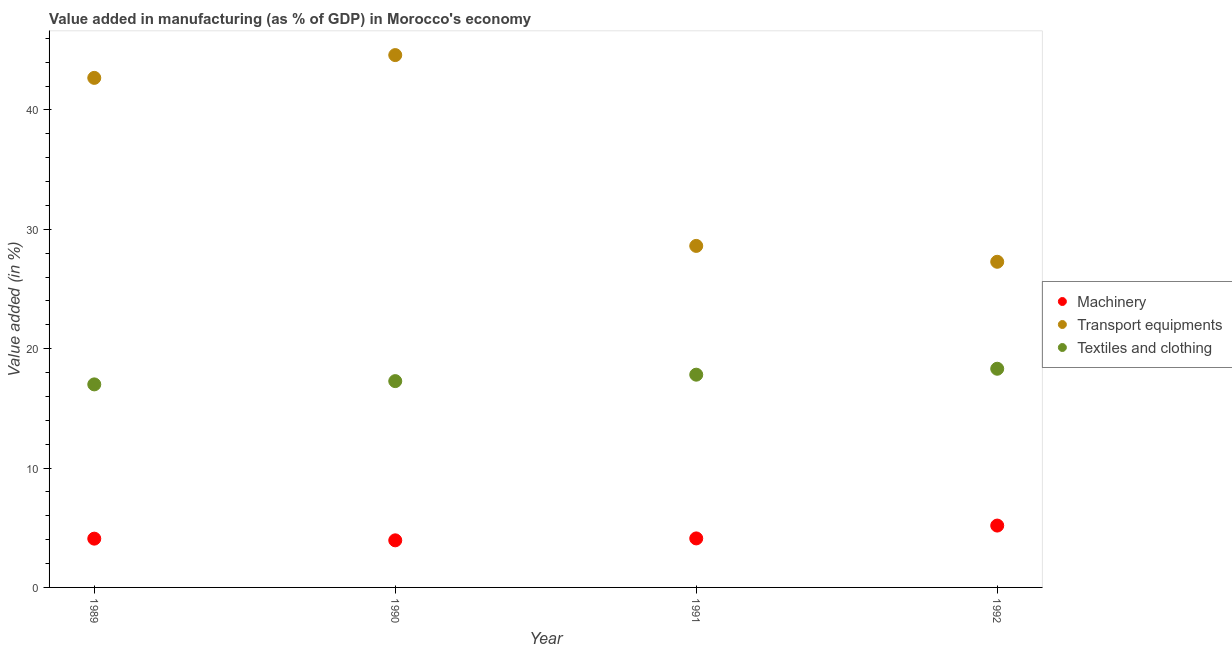Is the number of dotlines equal to the number of legend labels?
Make the answer very short. Yes. What is the value added in manufacturing machinery in 1992?
Offer a very short reply. 5.18. Across all years, what is the maximum value added in manufacturing machinery?
Your answer should be compact. 5.18. Across all years, what is the minimum value added in manufacturing textile and clothing?
Offer a terse response. 17.01. In which year was the value added in manufacturing textile and clothing maximum?
Ensure brevity in your answer.  1992. In which year was the value added in manufacturing textile and clothing minimum?
Your answer should be compact. 1989. What is the total value added in manufacturing transport equipments in the graph?
Keep it short and to the point. 143.19. What is the difference between the value added in manufacturing transport equipments in 1989 and that in 1990?
Ensure brevity in your answer.  -1.91. What is the difference between the value added in manufacturing machinery in 1989 and the value added in manufacturing transport equipments in 1990?
Make the answer very short. -40.51. What is the average value added in manufacturing machinery per year?
Make the answer very short. 4.33. In the year 1991, what is the difference between the value added in manufacturing transport equipments and value added in manufacturing machinery?
Ensure brevity in your answer.  24.51. What is the ratio of the value added in manufacturing machinery in 1989 to that in 1990?
Your answer should be very brief. 1.04. Is the value added in manufacturing machinery in 1989 less than that in 1990?
Your answer should be compact. No. What is the difference between the highest and the second highest value added in manufacturing machinery?
Your answer should be very brief. 1.08. What is the difference between the highest and the lowest value added in manufacturing textile and clothing?
Give a very brief answer. 1.31. Is it the case that in every year, the sum of the value added in manufacturing machinery and value added in manufacturing transport equipments is greater than the value added in manufacturing textile and clothing?
Your answer should be very brief. Yes. How many dotlines are there?
Keep it short and to the point. 3. What is the difference between two consecutive major ticks on the Y-axis?
Ensure brevity in your answer.  10. Are the values on the major ticks of Y-axis written in scientific E-notation?
Ensure brevity in your answer.  No. Does the graph contain any zero values?
Offer a terse response. No. How many legend labels are there?
Make the answer very short. 3. How are the legend labels stacked?
Ensure brevity in your answer.  Vertical. What is the title of the graph?
Keep it short and to the point. Value added in manufacturing (as % of GDP) in Morocco's economy. Does "Taxes on goods and services" appear as one of the legend labels in the graph?
Your answer should be very brief. No. What is the label or title of the X-axis?
Ensure brevity in your answer.  Year. What is the label or title of the Y-axis?
Your answer should be very brief. Value added (in %). What is the Value added (in %) in Machinery in 1989?
Keep it short and to the point. 4.09. What is the Value added (in %) of Transport equipments in 1989?
Make the answer very short. 42.69. What is the Value added (in %) of Textiles and clothing in 1989?
Keep it short and to the point. 17.01. What is the Value added (in %) in Machinery in 1990?
Make the answer very short. 3.95. What is the Value added (in %) of Transport equipments in 1990?
Keep it short and to the point. 44.6. What is the Value added (in %) in Textiles and clothing in 1990?
Give a very brief answer. 17.28. What is the Value added (in %) of Machinery in 1991?
Your answer should be compact. 4.11. What is the Value added (in %) of Transport equipments in 1991?
Provide a succinct answer. 28.61. What is the Value added (in %) of Textiles and clothing in 1991?
Your answer should be very brief. 17.83. What is the Value added (in %) of Machinery in 1992?
Offer a very short reply. 5.18. What is the Value added (in %) in Transport equipments in 1992?
Offer a very short reply. 27.28. What is the Value added (in %) of Textiles and clothing in 1992?
Your answer should be very brief. 18.32. Across all years, what is the maximum Value added (in %) of Machinery?
Ensure brevity in your answer.  5.18. Across all years, what is the maximum Value added (in %) in Transport equipments?
Offer a terse response. 44.6. Across all years, what is the maximum Value added (in %) of Textiles and clothing?
Make the answer very short. 18.32. Across all years, what is the minimum Value added (in %) of Machinery?
Provide a short and direct response. 3.95. Across all years, what is the minimum Value added (in %) in Transport equipments?
Provide a short and direct response. 27.28. Across all years, what is the minimum Value added (in %) in Textiles and clothing?
Make the answer very short. 17.01. What is the total Value added (in %) of Machinery in the graph?
Make the answer very short. 17.32. What is the total Value added (in %) of Transport equipments in the graph?
Keep it short and to the point. 143.19. What is the total Value added (in %) in Textiles and clothing in the graph?
Offer a very short reply. 70.44. What is the difference between the Value added (in %) of Machinery in 1989 and that in 1990?
Keep it short and to the point. 0.14. What is the difference between the Value added (in %) of Transport equipments in 1989 and that in 1990?
Offer a very short reply. -1.91. What is the difference between the Value added (in %) of Textiles and clothing in 1989 and that in 1990?
Keep it short and to the point. -0.27. What is the difference between the Value added (in %) in Machinery in 1989 and that in 1991?
Keep it short and to the point. -0.02. What is the difference between the Value added (in %) in Transport equipments in 1989 and that in 1991?
Offer a terse response. 14.08. What is the difference between the Value added (in %) of Textiles and clothing in 1989 and that in 1991?
Make the answer very short. -0.81. What is the difference between the Value added (in %) of Machinery in 1989 and that in 1992?
Your response must be concise. -1.1. What is the difference between the Value added (in %) of Transport equipments in 1989 and that in 1992?
Your answer should be compact. 15.41. What is the difference between the Value added (in %) of Textiles and clothing in 1989 and that in 1992?
Your answer should be compact. -1.31. What is the difference between the Value added (in %) of Machinery in 1990 and that in 1991?
Keep it short and to the point. -0.16. What is the difference between the Value added (in %) of Transport equipments in 1990 and that in 1991?
Your answer should be compact. 15.99. What is the difference between the Value added (in %) of Textiles and clothing in 1990 and that in 1991?
Ensure brevity in your answer.  -0.54. What is the difference between the Value added (in %) of Machinery in 1990 and that in 1992?
Provide a succinct answer. -1.24. What is the difference between the Value added (in %) in Transport equipments in 1990 and that in 1992?
Your response must be concise. 17.32. What is the difference between the Value added (in %) in Textiles and clothing in 1990 and that in 1992?
Provide a succinct answer. -1.04. What is the difference between the Value added (in %) of Machinery in 1991 and that in 1992?
Your response must be concise. -1.08. What is the difference between the Value added (in %) in Transport equipments in 1991 and that in 1992?
Make the answer very short. 1.33. What is the difference between the Value added (in %) of Textiles and clothing in 1991 and that in 1992?
Make the answer very short. -0.5. What is the difference between the Value added (in %) of Machinery in 1989 and the Value added (in %) of Transport equipments in 1990?
Offer a terse response. -40.51. What is the difference between the Value added (in %) of Machinery in 1989 and the Value added (in %) of Textiles and clothing in 1990?
Your answer should be compact. -13.2. What is the difference between the Value added (in %) in Transport equipments in 1989 and the Value added (in %) in Textiles and clothing in 1990?
Your response must be concise. 25.41. What is the difference between the Value added (in %) in Machinery in 1989 and the Value added (in %) in Transport equipments in 1991?
Your answer should be compact. -24.53. What is the difference between the Value added (in %) of Machinery in 1989 and the Value added (in %) of Textiles and clothing in 1991?
Your answer should be compact. -13.74. What is the difference between the Value added (in %) of Transport equipments in 1989 and the Value added (in %) of Textiles and clothing in 1991?
Your answer should be compact. 24.87. What is the difference between the Value added (in %) in Machinery in 1989 and the Value added (in %) in Transport equipments in 1992?
Provide a succinct answer. -23.2. What is the difference between the Value added (in %) of Machinery in 1989 and the Value added (in %) of Textiles and clothing in 1992?
Provide a succinct answer. -14.23. What is the difference between the Value added (in %) of Transport equipments in 1989 and the Value added (in %) of Textiles and clothing in 1992?
Your answer should be very brief. 24.37. What is the difference between the Value added (in %) in Machinery in 1990 and the Value added (in %) in Transport equipments in 1991?
Ensure brevity in your answer.  -24.67. What is the difference between the Value added (in %) of Machinery in 1990 and the Value added (in %) of Textiles and clothing in 1991?
Provide a succinct answer. -13.88. What is the difference between the Value added (in %) in Transport equipments in 1990 and the Value added (in %) in Textiles and clothing in 1991?
Your answer should be compact. 26.78. What is the difference between the Value added (in %) of Machinery in 1990 and the Value added (in %) of Transport equipments in 1992?
Provide a short and direct response. -23.34. What is the difference between the Value added (in %) of Machinery in 1990 and the Value added (in %) of Textiles and clothing in 1992?
Ensure brevity in your answer.  -14.38. What is the difference between the Value added (in %) in Transport equipments in 1990 and the Value added (in %) in Textiles and clothing in 1992?
Offer a very short reply. 26.28. What is the difference between the Value added (in %) of Machinery in 1991 and the Value added (in %) of Transport equipments in 1992?
Your answer should be very brief. -23.18. What is the difference between the Value added (in %) of Machinery in 1991 and the Value added (in %) of Textiles and clothing in 1992?
Your answer should be very brief. -14.21. What is the difference between the Value added (in %) of Transport equipments in 1991 and the Value added (in %) of Textiles and clothing in 1992?
Offer a terse response. 10.29. What is the average Value added (in %) of Machinery per year?
Your response must be concise. 4.33. What is the average Value added (in %) of Transport equipments per year?
Provide a succinct answer. 35.8. What is the average Value added (in %) in Textiles and clothing per year?
Keep it short and to the point. 17.61. In the year 1989, what is the difference between the Value added (in %) in Machinery and Value added (in %) in Transport equipments?
Keep it short and to the point. -38.6. In the year 1989, what is the difference between the Value added (in %) in Machinery and Value added (in %) in Textiles and clothing?
Offer a terse response. -12.92. In the year 1989, what is the difference between the Value added (in %) in Transport equipments and Value added (in %) in Textiles and clothing?
Make the answer very short. 25.68. In the year 1990, what is the difference between the Value added (in %) in Machinery and Value added (in %) in Transport equipments?
Give a very brief answer. -40.65. In the year 1990, what is the difference between the Value added (in %) in Machinery and Value added (in %) in Textiles and clothing?
Your answer should be very brief. -13.34. In the year 1990, what is the difference between the Value added (in %) of Transport equipments and Value added (in %) of Textiles and clothing?
Offer a very short reply. 27.32. In the year 1991, what is the difference between the Value added (in %) of Machinery and Value added (in %) of Transport equipments?
Offer a very short reply. -24.51. In the year 1991, what is the difference between the Value added (in %) in Machinery and Value added (in %) in Textiles and clothing?
Offer a terse response. -13.72. In the year 1991, what is the difference between the Value added (in %) in Transport equipments and Value added (in %) in Textiles and clothing?
Offer a very short reply. 10.79. In the year 1992, what is the difference between the Value added (in %) in Machinery and Value added (in %) in Transport equipments?
Provide a short and direct response. -22.1. In the year 1992, what is the difference between the Value added (in %) in Machinery and Value added (in %) in Textiles and clothing?
Your answer should be very brief. -13.14. In the year 1992, what is the difference between the Value added (in %) in Transport equipments and Value added (in %) in Textiles and clothing?
Provide a succinct answer. 8.96. What is the ratio of the Value added (in %) of Machinery in 1989 to that in 1990?
Your answer should be very brief. 1.04. What is the ratio of the Value added (in %) in Transport equipments in 1989 to that in 1990?
Provide a succinct answer. 0.96. What is the ratio of the Value added (in %) in Textiles and clothing in 1989 to that in 1990?
Provide a short and direct response. 0.98. What is the ratio of the Value added (in %) of Transport equipments in 1989 to that in 1991?
Offer a terse response. 1.49. What is the ratio of the Value added (in %) of Textiles and clothing in 1989 to that in 1991?
Offer a very short reply. 0.95. What is the ratio of the Value added (in %) in Machinery in 1989 to that in 1992?
Your answer should be compact. 0.79. What is the ratio of the Value added (in %) of Transport equipments in 1989 to that in 1992?
Give a very brief answer. 1.56. What is the ratio of the Value added (in %) in Textiles and clothing in 1989 to that in 1992?
Offer a terse response. 0.93. What is the ratio of the Value added (in %) of Machinery in 1990 to that in 1991?
Your answer should be very brief. 0.96. What is the ratio of the Value added (in %) in Transport equipments in 1990 to that in 1991?
Give a very brief answer. 1.56. What is the ratio of the Value added (in %) of Textiles and clothing in 1990 to that in 1991?
Provide a succinct answer. 0.97. What is the ratio of the Value added (in %) in Machinery in 1990 to that in 1992?
Offer a very short reply. 0.76. What is the ratio of the Value added (in %) of Transport equipments in 1990 to that in 1992?
Offer a terse response. 1.63. What is the ratio of the Value added (in %) in Textiles and clothing in 1990 to that in 1992?
Offer a very short reply. 0.94. What is the ratio of the Value added (in %) of Machinery in 1991 to that in 1992?
Your answer should be very brief. 0.79. What is the ratio of the Value added (in %) in Transport equipments in 1991 to that in 1992?
Keep it short and to the point. 1.05. What is the ratio of the Value added (in %) of Textiles and clothing in 1991 to that in 1992?
Offer a terse response. 0.97. What is the difference between the highest and the second highest Value added (in %) of Machinery?
Offer a terse response. 1.08. What is the difference between the highest and the second highest Value added (in %) of Transport equipments?
Provide a short and direct response. 1.91. What is the difference between the highest and the second highest Value added (in %) of Textiles and clothing?
Offer a very short reply. 0.5. What is the difference between the highest and the lowest Value added (in %) in Machinery?
Your response must be concise. 1.24. What is the difference between the highest and the lowest Value added (in %) of Transport equipments?
Your answer should be very brief. 17.32. What is the difference between the highest and the lowest Value added (in %) of Textiles and clothing?
Provide a succinct answer. 1.31. 